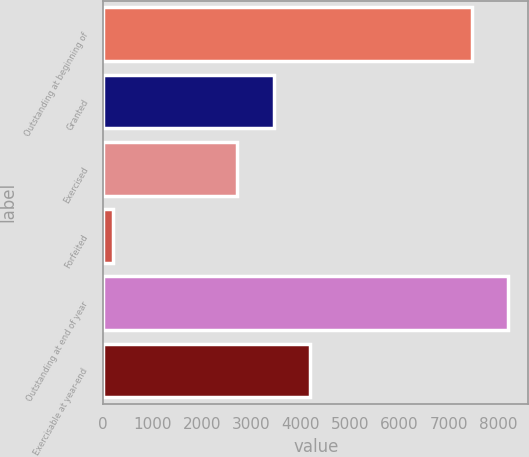<chart> <loc_0><loc_0><loc_500><loc_500><bar_chart><fcel>Outstanding at beginning of<fcel>Granted<fcel>Exercised<fcel>Forfeited<fcel>Outstanding at end of year<fcel>Exercisable at year-end<nl><fcel>7467<fcel>3447<fcel>2717<fcel>195<fcel>8197<fcel>4177<nl></chart> 